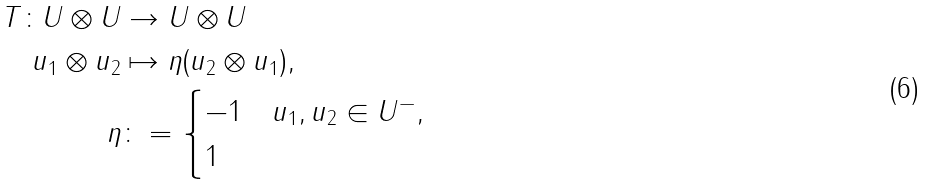<formula> <loc_0><loc_0><loc_500><loc_500>T \colon U \otimes U & \to U \otimes U \\ u _ { 1 } \otimes u _ { 2 } & \mapsto \eta ( u _ { 2 } \otimes u _ { 1 } ) , \\ \eta & \colon = \begin{cases} - 1 & u _ { 1 } , u _ { 2 } \in U ^ { - } , \\ 1 & \end{cases}</formula> 